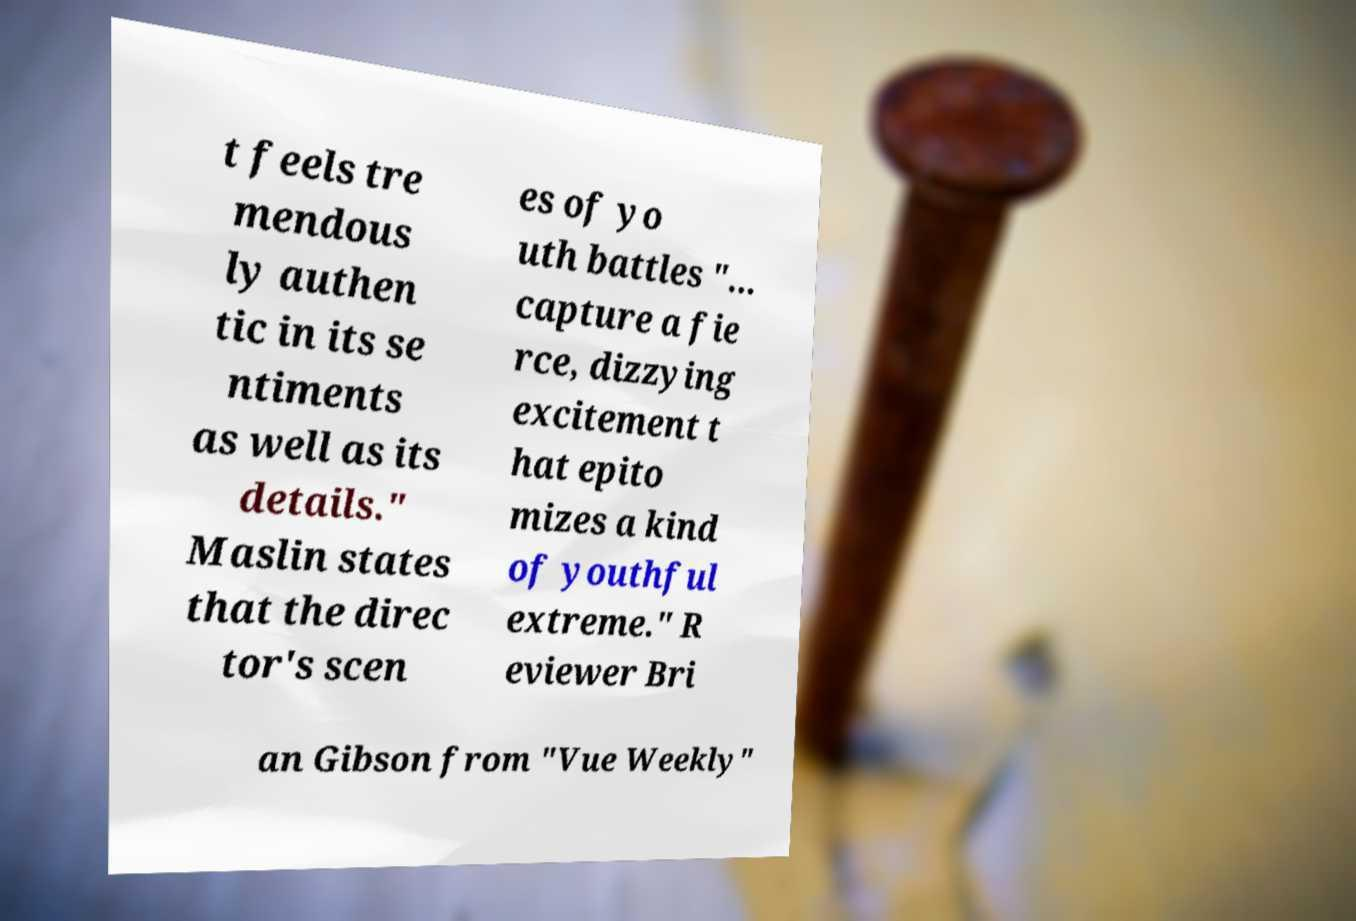Please identify and transcribe the text found in this image. t feels tre mendous ly authen tic in its se ntiments as well as its details." Maslin states that the direc tor's scen es of yo uth battles "... capture a fie rce, dizzying excitement t hat epito mizes a kind of youthful extreme." R eviewer Bri an Gibson from "Vue Weekly" 